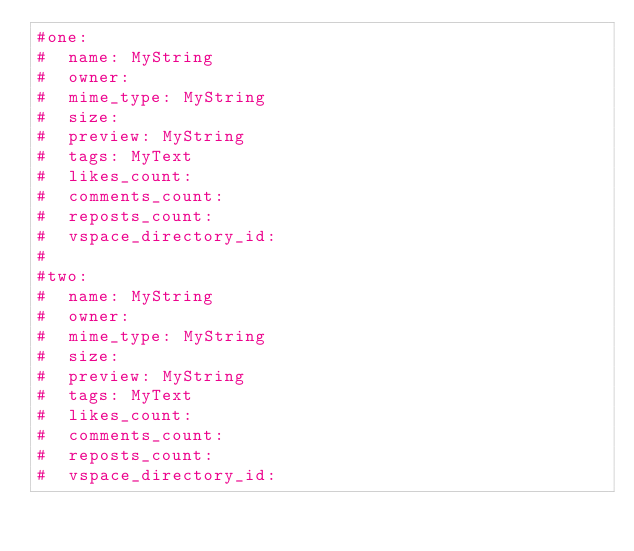Convert code to text. <code><loc_0><loc_0><loc_500><loc_500><_YAML_>#one:
#  name: MyString
#  owner:
#  mime_type: MyString
#  size:
#  preview: MyString
#  tags: MyText
#  likes_count:
#  comments_count:
#  reposts_count:
#  vspace_directory_id:
#
#two:
#  name: MyString
#  owner:
#  mime_type: MyString
#  size:
#  preview: MyString
#  tags: MyText
#  likes_count:
#  comments_count:
#  reposts_count:
#  vspace_directory_id:
</code> 